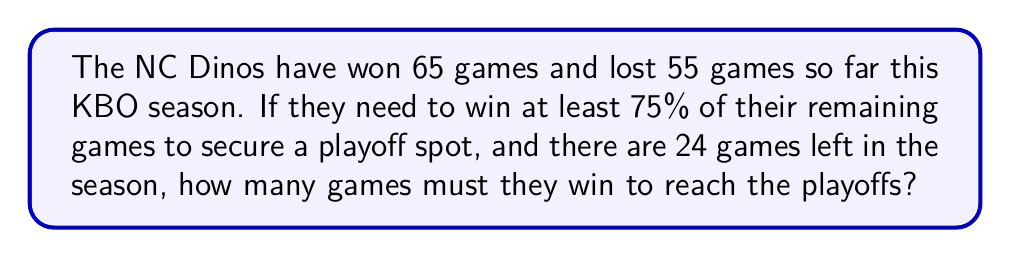Solve this math problem. Let's approach this step-by-step:

1) First, we need to calculate how many games the NC Dinos must win out of the remaining 24 games to reach a 75% win rate for these games.

   Let $x$ be the number of games they need to win.
   
   $$\frac{x}{24} \geq 0.75$$

2) Solving for $x$:
   
   $$x \geq 24 * 0.75 = 18$$

3) Since we can't win a fraction of a game, we round up to the nearest whole number. So the Dinos need to win at least 18 games out of the remaining 24.

4) Now, let's verify if this will be enough for a playoff spot. We need to calculate the total win percentage after these additional wins:

   Total games played: $65 + 55 + 24 = 144$
   Total wins if they win 18 more: $65 + 18 = 83$

   Win percentage: $$\frac{83}{144} \approx 0.5764 \text{ or about } 57.64\%$$

5) While this might be enough for a playoff spot (depending on other teams' performances), it satisfies the condition given in the problem of winning at least 75% of the remaining games.
Answer: 18 games 